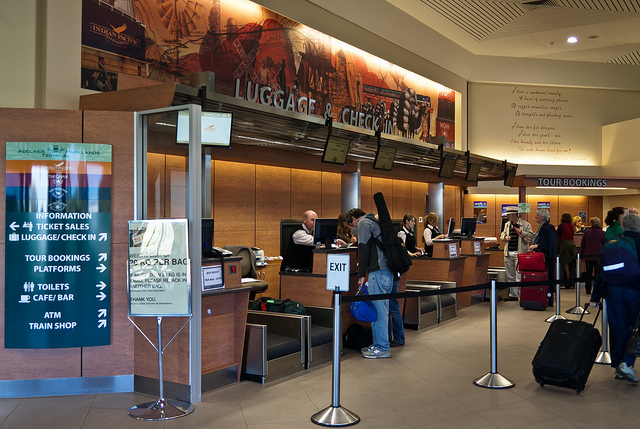Is there any indication of the location or the name of the station? The image doesn't provide clear text that indicates the specific name or location of the station. However, the infrastructure and signage style might offer some clues to those familiar with the region or local transit systems. 